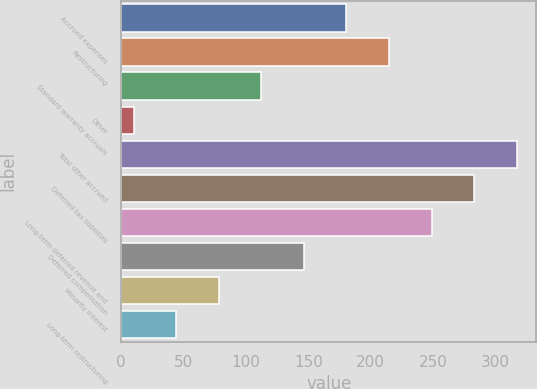Convert chart to OTSL. <chart><loc_0><loc_0><loc_500><loc_500><bar_chart><fcel>Accrued expenses<fcel>Restructuring<fcel>Standard warranty accruals<fcel>Other<fcel>Total other accrued<fcel>Deferred tax liabilities<fcel>Long-term deferred revenue and<fcel>Deferred compensation<fcel>Minority interest<fcel>Long-term restructuring<nl><fcel>180.5<fcel>214.6<fcel>112.3<fcel>10<fcel>316.9<fcel>282.8<fcel>248.7<fcel>146.4<fcel>78.2<fcel>44.1<nl></chart> 